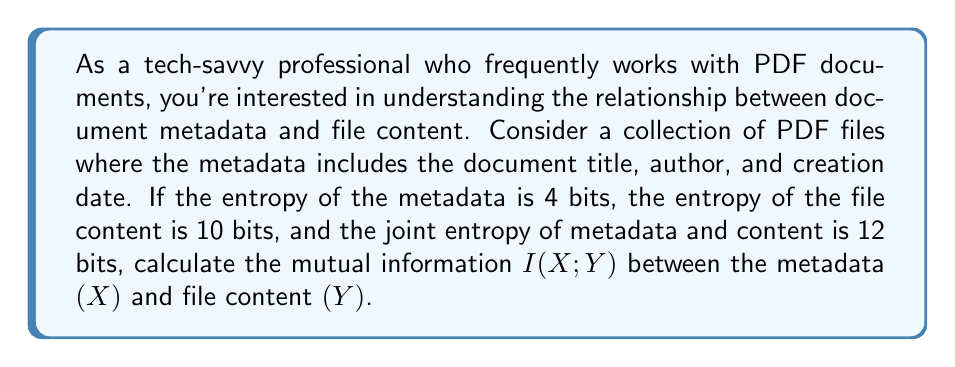Could you help me with this problem? To solve this problem, we'll use the formula for mutual information in terms of entropy:

$$I(X;Y) = H(X) + H(Y) - H(X,Y)$$

Where:
- $I(X;Y)$ is the mutual information between X and Y
- $H(X)$ is the entropy of X (metadata)
- $H(Y)$ is the entropy of Y (file content)
- $H(X,Y)$ is the joint entropy of X and Y

We're given:
- $H(X) = 4$ bits (entropy of metadata)
- $H(Y) = 10$ bits (entropy of file content)
- $H(X,Y) = 12$ bits (joint entropy of metadata and content)

Now, let's substitute these values into the formula:

$$I(X;Y) = H(X) + H(Y) - H(X,Y)$$
$$I(X;Y) = 4 + 10 - 12$$
$$I(X;Y) = 2$$

Therefore, the mutual information between the document metadata and file content is 2 bits.

This result indicates that there is some shared information between the metadata and the content. In practical terms, this means that knowing the metadata provides some information about the content, and vice versa. For example, the document title in the metadata might give clues about the content of the PDF file.
Answer: The mutual information $I(X;Y)$ between the document metadata and file content is 2 bits. 